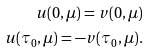Convert formula to latex. <formula><loc_0><loc_0><loc_500><loc_500>u ( 0 , \mu ) = v ( 0 , \mu ) \\ u ( \tau _ { 0 } , \mu ) = - v ( \tau _ { 0 } , \mu ) .</formula> 